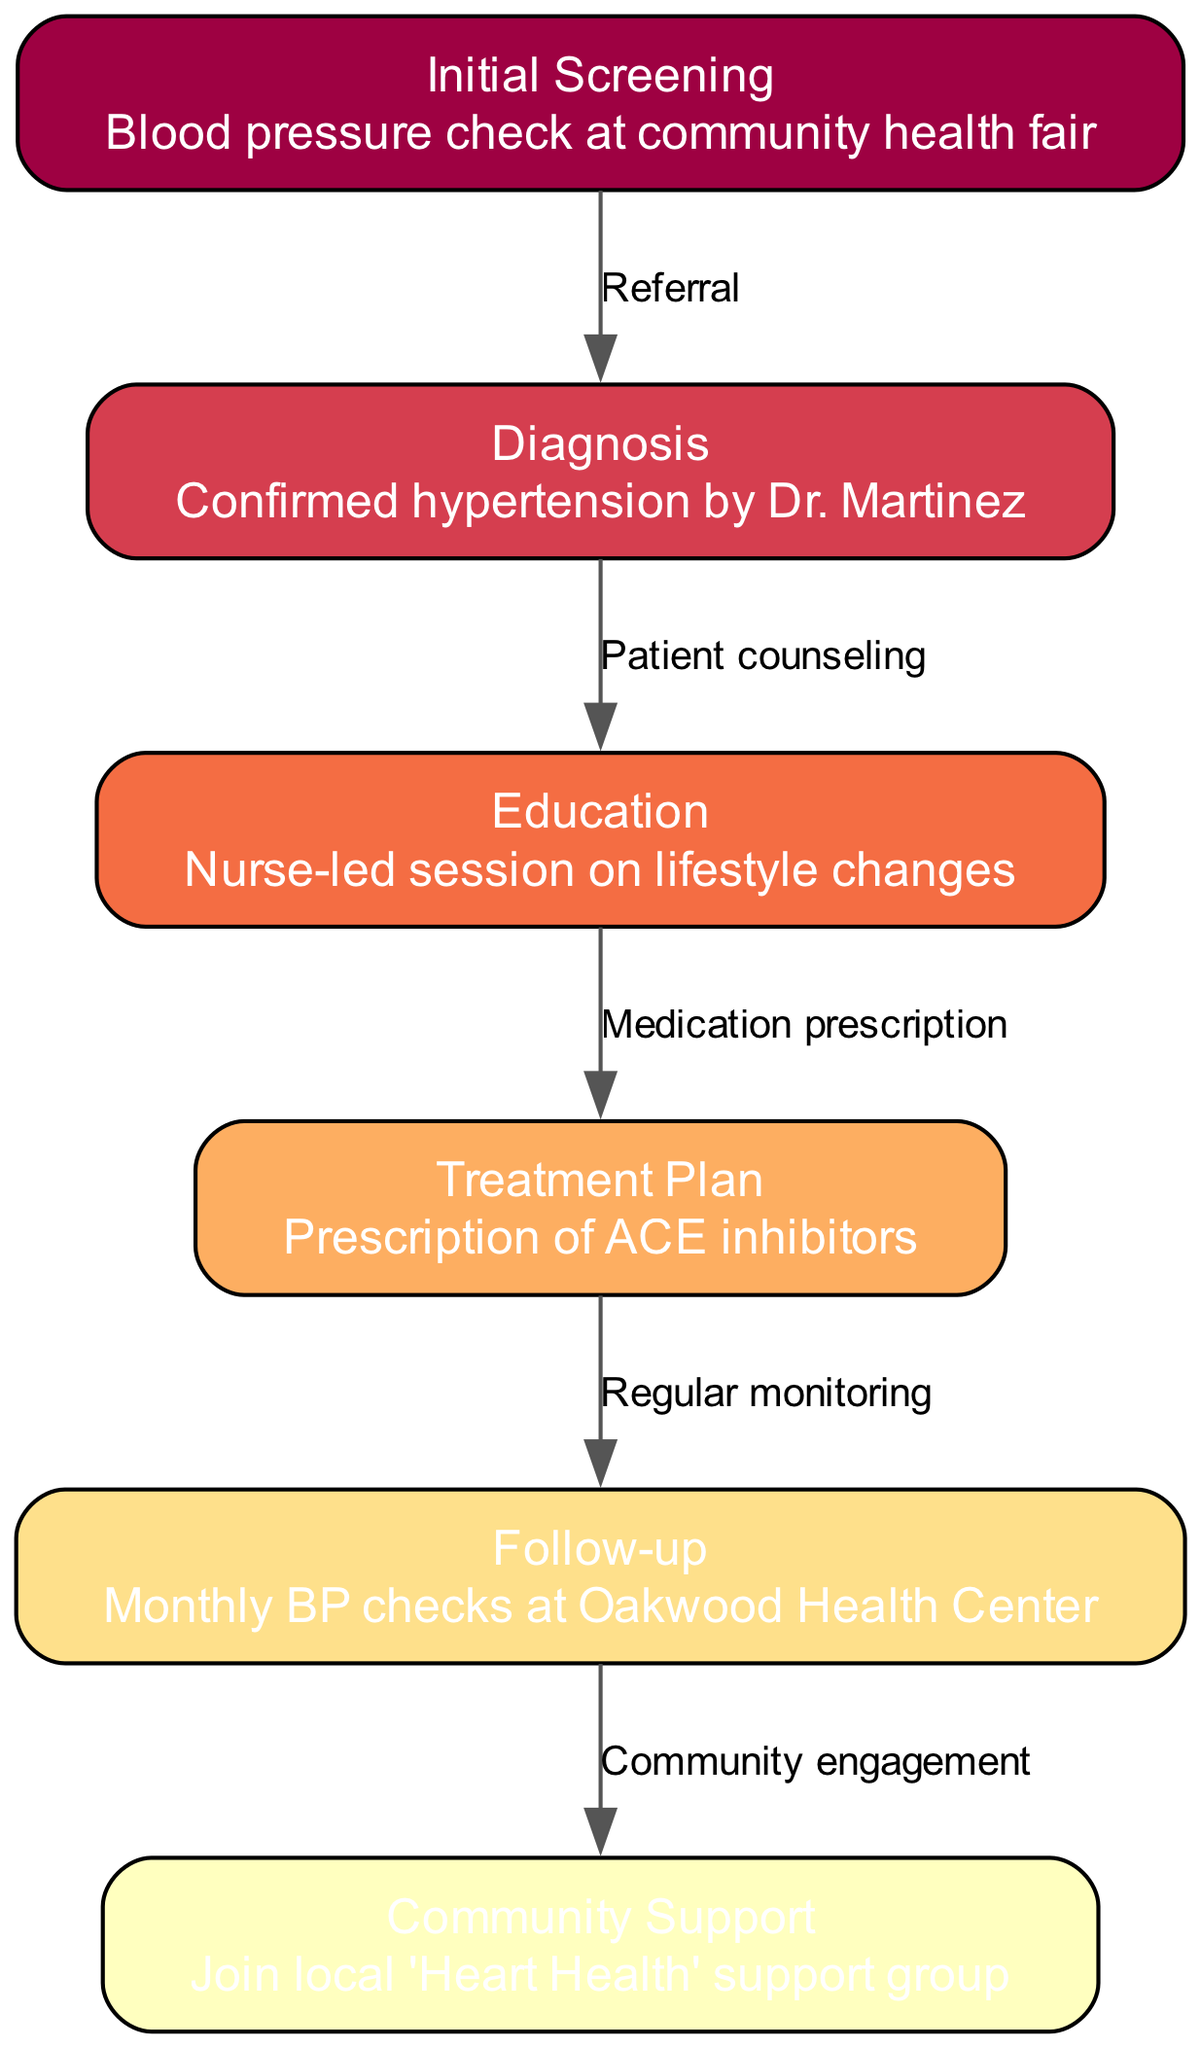What is the first step in the patient journey? The diagram shows "Initial Screening" as the first node. It indicates the starting point for the patient journey, which involves a blood pressure check at a community health fair.
Answer: Initial Screening How many nodes are there in total? Counting the nodes listed in the diagram, there are six distinct steps in the patient journey for managing hypertension.
Answer: 6 What is the edge label between "Diagnosis" and "Education"? The edge between "Diagnosis" and "Education" is labeled "Patient counseling," indicating the relationship of providing information after the diagnosis.
Answer: Patient counseling Which medication is included in the treatment plan? The treatment plan node specifically mentions the prescription of ACE inhibitors, which is the medication referred to.
Answer: ACE inhibitors What action follows the "Follow-up" step? The diagram indicates that after the "Follow-up" step, the subsequent action is "Community Support," highlighting the importance of social engagement after monitoring.
Answer: Community Support How does a patient transition from "Initial Screening" to "Diagnosis"? The transition from "Initial Screening" to "Diagnosis" is indicated by the edge labeled "Referral," which means that patients are referred for further evaluation after the initial screening.
Answer: Referral What role does the nurse play in the management of hypertension? According to the diagram, the nurse’s role is detailed in the "Education" step, where they conduct a nurse-led session on lifestyle changes for patients.
Answer: Nurse-led session What is the significance of joining the "Community Support" group? The "Community Support" node follows from "Follow-up" and signifies a step towards building a support network for patients, enhancing their ongoing management of hypertension.
Answer: Community Support 